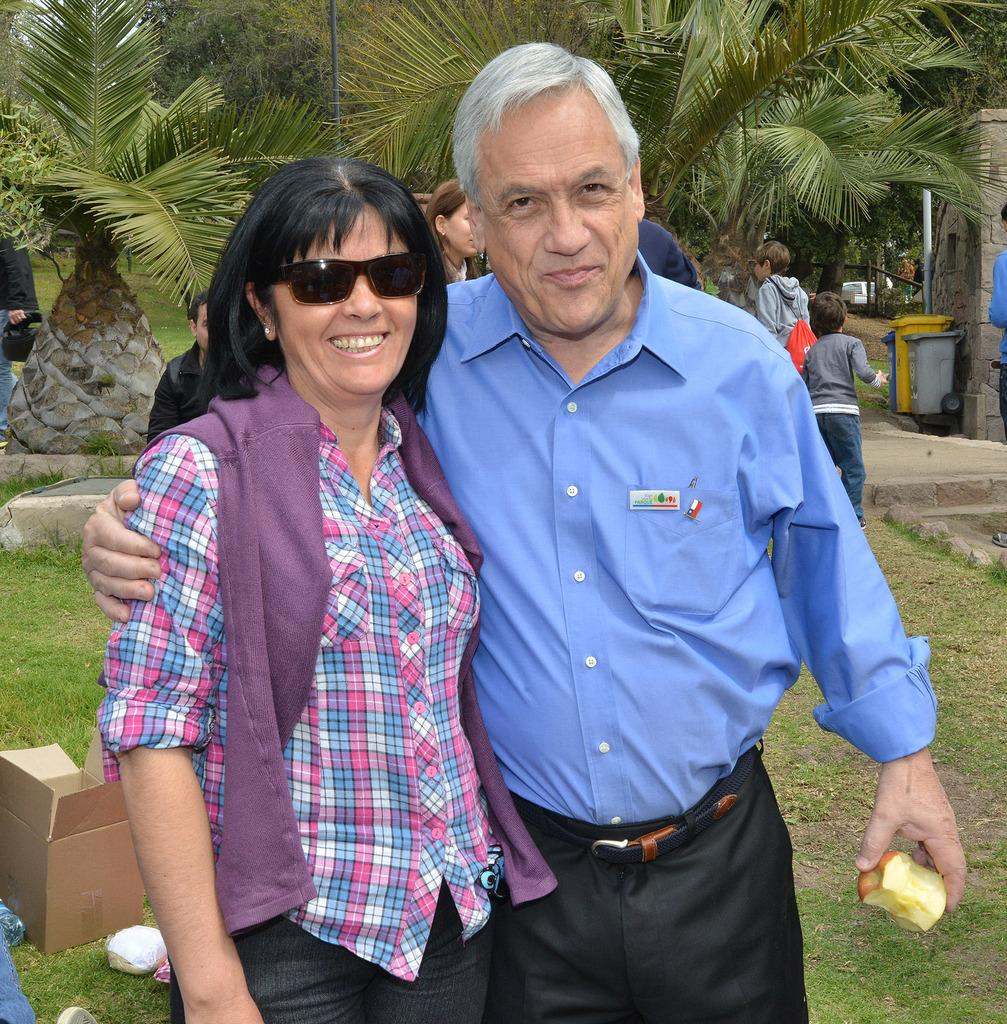How many people are in the image? There are two people standing in the image. What is one person holding? One person is holding an apple. Can you describe the background of the image? In the background, there are people, trees, dustbins, a cardboard box, and objects on the ground. What might the objects on the ground be used for? The objects on the ground could be used for various purposes, but without more information, it's difficult to determine their specific use. What type of glue is being used to attach the shoe to the tree in the image? There is no glue or shoe present in the image; it only features two people, an apple, and various background elements. 